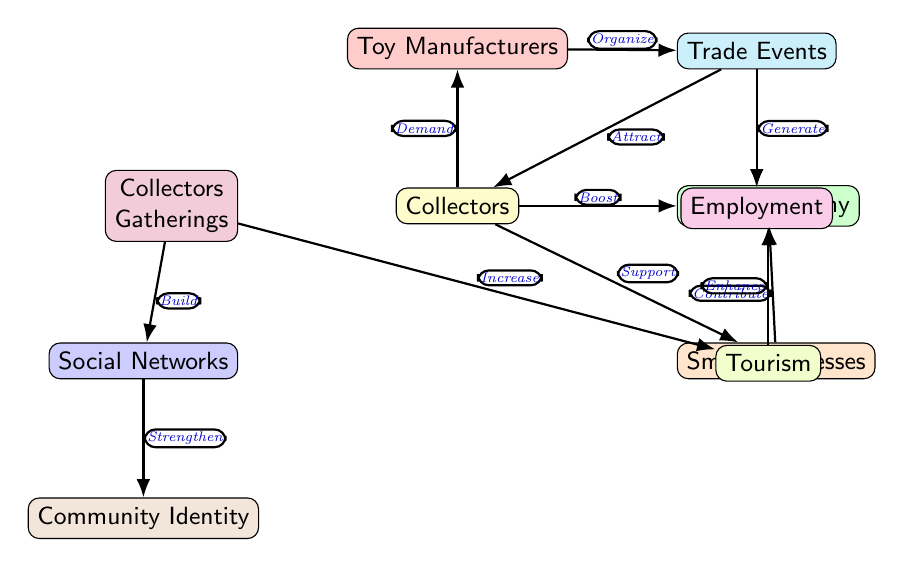What node receives a boost from Collectors? The relationship indicated by the edge labeled "Boost" shows that Collectors directly influence the Local Economy, meaning that the Local Economy is boosted by Collectors' activities.
Answer: Local Economy How many edges connect to Small Businesses? By counting the edges connected to the Small Businesses node, we see that there are two edges: one coming from Collectors (labeled "Support") and another leading to Local Economy (labeled "Contribute").
Answer: 2 What effect do Collectors Gatherings have on Social Networks? The edge labeled "Build" indicates that Collectors Gatherings directly influence and strengthen Social Networks. Thus, the connection shows a positive effect between these two nodes.
Answer: Build Which node contributes to Employment? The edge labeled "Generate" shows that Trade Events directly influence and contribute to Employment. Therefore, Trade Events is the node that contributes to Employment.
Answer: Trade Events What is the relationship between Social Networks and Community Identity? The edge labeled "Strengthen" indicates that Social Networks play a role in fortifying or enhancing Community Identity. This shows a supportive relationship between these nodes.
Answer: Strengthen Which node does the Collectors demand toys from? The edge labeled "Demand" illustrates that Collectors have a demand that directly affects Toy Manufacturers, signifying a direct relationship between them.
Answer: Toy Manufacturers How many total nodes are represented in this diagram? By counting all the distinct nodes in the diagram, we find that there are a total of ten nodes, each representing different aspects of the community and economic impact of toy collecting.
Answer: 10 What does Tourism do in relation to the Local Economy? The edge labeled "Enhance" shows that Tourism has a positive impact on the Local Economy, demonstrating that an increase in tourism contributes to the improvement of the local economic situation.
Answer: Enhance Which node attracts Collectors during Trade Events? The edge labeled "Attract" indicates that Trade Events serve to draw in or attract Collectors, implying that the events are designed to cater to their interests.
Answer: Attract 